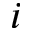Convert formula to latex. <formula><loc_0><loc_0><loc_500><loc_500>i</formula> 